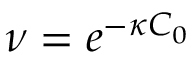Convert formula to latex. <formula><loc_0><loc_0><loc_500><loc_500>\nu = e ^ { - \kappa C _ { 0 } }</formula> 